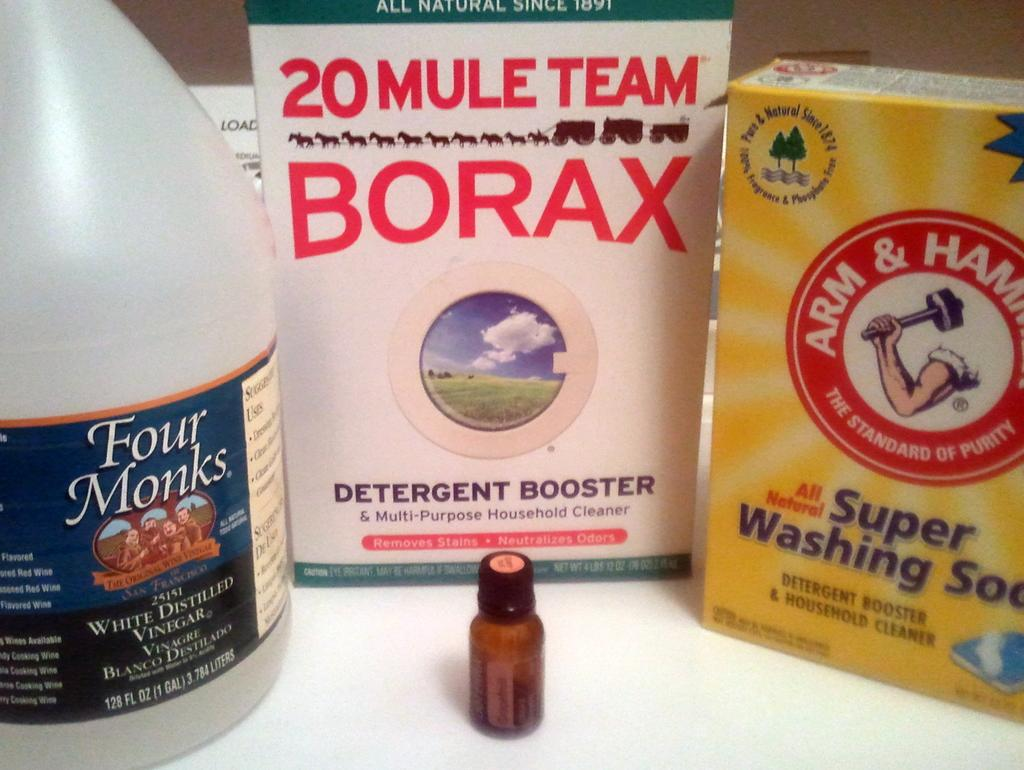<image>
Create a compact narrative representing the image presented. Different boxes of cleaning supplies such as Arm and Hammer and Borax sit on a white table. 